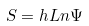<formula> <loc_0><loc_0><loc_500><loc_500>S = h L n \Psi</formula> 